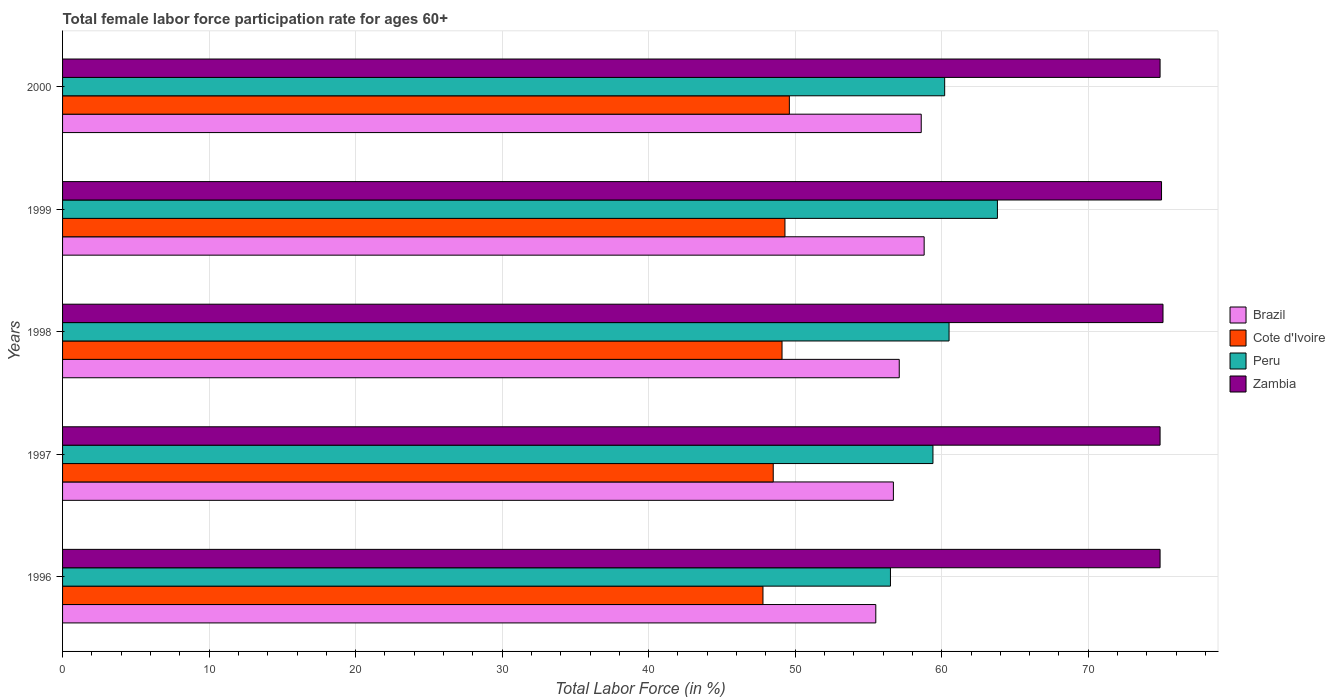How many groups of bars are there?
Offer a very short reply. 5. Are the number of bars per tick equal to the number of legend labels?
Provide a short and direct response. Yes. In how many cases, is the number of bars for a given year not equal to the number of legend labels?
Your answer should be very brief. 0. What is the female labor force participation rate in Peru in 2000?
Provide a succinct answer. 60.2. Across all years, what is the maximum female labor force participation rate in Brazil?
Give a very brief answer. 58.8. Across all years, what is the minimum female labor force participation rate in Brazil?
Provide a short and direct response. 55.5. In which year was the female labor force participation rate in Cote d'Ivoire maximum?
Keep it short and to the point. 2000. In which year was the female labor force participation rate in Zambia minimum?
Give a very brief answer. 1996. What is the total female labor force participation rate in Peru in the graph?
Keep it short and to the point. 300.4. What is the difference between the female labor force participation rate in Brazil in 1996 and that in 1998?
Your answer should be compact. -1.6. What is the difference between the female labor force participation rate in Brazil in 1998 and the female labor force participation rate in Peru in 1999?
Make the answer very short. -6.7. What is the average female labor force participation rate in Brazil per year?
Your answer should be very brief. 57.34. In the year 1998, what is the difference between the female labor force participation rate in Brazil and female labor force participation rate in Zambia?
Your answer should be very brief. -18. What is the ratio of the female labor force participation rate in Zambia in 1998 to that in 2000?
Provide a succinct answer. 1. Is the female labor force participation rate in Peru in 1998 less than that in 2000?
Ensure brevity in your answer.  No. What is the difference between the highest and the second highest female labor force participation rate in Peru?
Your response must be concise. 3.3. What is the difference between the highest and the lowest female labor force participation rate in Cote d'Ivoire?
Ensure brevity in your answer.  1.8. In how many years, is the female labor force participation rate in Cote d'Ivoire greater than the average female labor force participation rate in Cote d'Ivoire taken over all years?
Keep it short and to the point. 3. Is the sum of the female labor force participation rate in Brazil in 1996 and 1998 greater than the maximum female labor force participation rate in Cote d'Ivoire across all years?
Offer a terse response. Yes. What does the 1st bar from the top in 2000 represents?
Make the answer very short. Zambia. What does the 3rd bar from the bottom in 1996 represents?
Your answer should be very brief. Peru. Is it the case that in every year, the sum of the female labor force participation rate in Brazil and female labor force participation rate in Peru is greater than the female labor force participation rate in Zambia?
Keep it short and to the point. Yes. How many bars are there?
Offer a very short reply. 20. Are all the bars in the graph horizontal?
Your answer should be very brief. Yes. Where does the legend appear in the graph?
Make the answer very short. Center right. How many legend labels are there?
Your response must be concise. 4. What is the title of the graph?
Your response must be concise. Total female labor force participation rate for ages 60+. Does "Belarus" appear as one of the legend labels in the graph?
Your answer should be very brief. No. What is the label or title of the X-axis?
Provide a short and direct response. Total Labor Force (in %). What is the label or title of the Y-axis?
Provide a succinct answer. Years. What is the Total Labor Force (in %) in Brazil in 1996?
Keep it short and to the point. 55.5. What is the Total Labor Force (in %) in Cote d'Ivoire in 1996?
Offer a terse response. 47.8. What is the Total Labor Force (in %) of Peru in 1996?
Make the answer very short. 56.5. What is the Total Labor Force (in %) in Zambia in 1996?
Your answer should be very brief. 74.9. What is the Total Labor Force (in %) in Brazil in 1997?
Make the answer very short. 56.7. What is the Total Labor Force (in %) of Cote d'Ivoire in 1997?
Offer a terse response. 48.5. What is the Total Labor Force (in %) of Peru in 1997?
Ensure brevity in your answer.  59.4. What is the Total Labor Force (in %) in Zambia in 1997?
Provide a short and direct response. 74.9. What is the Total Labor Force (in %) in Brazil in 1998?
Offer a very short reply. 57.1. What is the Total Labor Force (in %) in Cote d'Ivoire in 1998?
Make the answer very short. 49.1. What is the Total Labor Force (in %) in Peru in 1998?
Offer a terse response. 60.5. What is the Total Labor Force (in %) of Zambia in 1998?
Your response must be concise. 75.1. What is the Total Labor Force (in %) in Brazil in 1999?
Make the answer very short. 58.8. What is the Total Labor Force (in %) in Cote d'Ivoire in 1999?
Provide a short and direct response. 49.3. What is the Total Labor Force (in %) in Peru in 1999?
Offer a terse response. 63.8. What is the Total Labor Force (in %) in Brazil in 2000?
Offer a terse response. 58.6. What is the Total Labor Force (in %) in Cote d'Ivoire in 2000?
Offer a very short reply. 49.6. What is the Total Labor Force (in %) of Peru in 2000?
Your response must be concise. 60.2. What is the Total Labor Force (in %) of Zambia in 2000?
Make the answer very short. 74.9. Across all years, what is the maximum Total Labor Force (in %) of Brazil?
Offer a terse response. 58.8. Across all years, what is the maximum Total Labor Force (in %) in Cote d'Ivoire?
Offer a terse response. 49.6. Across all years, what is the maximum Total Labor Force (in %) of Peru?
Make the answer very short. 63.8. Across all years, what is the maximum Total Labor Force (in %) of Zambia?
Your response must be concise. 75.1. Across all years, what is the minimum Total Labor Force (in %) of Brazil?
Your answer should be compact. 55.5. Across all years, what is the minimum Total Labor Force (in %) of Cote d'Ivoire?
Provide a succinct answer. 47.8. Across all years, what is the minimum Total Labor Force (in %) in Peru?
Your answer should be compact. 56.5. Across all years, what is the minimum Total Labor Force (in %) of Zambia?
Your response must be concise. 74.9. What is the total Total Labor Force (in %) in Brazil in the graph?
Your answer should be very brief. 286.7. What is the total Total Labor Force (in %) of Cote d'Ivoire in the graph?
Provide a short and direct response. 244.3. What is the total Total Labor Force (in %) of Peru in the graph?
Ensure brevity in your answer.  300.4. What is the total Total Labor Force (in %) in Zambia in the graph?
Give a very brief answer. 374.8. What is the difference between the Total Labor Force (in %) in Brazil in 1996 and that in 1997?
Offer a terse response. -1.2. What is the difference between the Total Labor Force (in %) in Peru in 1996 and that in 1997?
Make the answer very short. -2.9. What is the difference between the Total Labor Force (in %) of Brazil in 1996 and that in 1998?
Give a very brief answer. -1.6. What is the difference between the Total Labor Force (in %) of Cote d'Ivoire in 1996 and that in 1998?
Ensure brevity in your answer.  -1.3. What is the difference between the Total Labor Force (in %) of Peru in 1996 and that in 1998?
Offer a terse response. -4. What is the difference between the Total Labor Force (in %) of Zambia in 1996 and that in 1998?
Your answer should be very brief. -0.2. What is the difference between the Total Labor Force (in %) in Brazil in 1996 and that in 1999?
Ensure brevity in your answer.  -3.3. What is the difference between the Total Labor Force (in %) of Cote d'Ivoire in 1996 and that in 2000?
Make the answer very short. -1.8. What is the difference between the Total Labor Force (in %) in Peru in 1996 and that in 2000?
Offer a very short reply. -3.7. What is the difference between the Total Labor Force (in %) in Brazil in 1997 and that in 1998?
Ensure brevity in your answer.  -0.4. What is the difference between the Total Labor Force (in %) of Cote d'Ivoire in 1997 and that in 1998?
Make the answer very short. -0.6. What is the difference between the Total Labor Force (in %) of Peru in 1997 and that in 1998?
Ensure brevity in your answer.  -1.1. What is the difference between the Total Labor Force (in %) of Brazil in 1997 and that in 1999?
Your answer should be very brief. -2.1. What is the difference between the Total Labor Force (in %) of Peru in 1997 and that in 1999?
Your answer should be very brief. -4.4. What is the difference between the Total Labor Force (in %) in Zambia in 1997 and that in 1999?
Your response must be concise. -0.1. What is the difference between the Total Labor Force (in %) of Peru in 1997 and that in 2000?
Make the answer very short. -0.8. What is the difference between the Total Labor Force (in %) of Peru in 1998 and that in 1999?
Give a very brief answer. -3.3. What is the difference between the Total Labor Force (in %) in Brazil in 1998 and that in 2000?
Provide a short and direct response. -1.5. What is the difference between the Total Labor Force (in %) of Cote d'Ivoire in 1998 and that in 2000?
Keep it short and to the point. -0.5. What is the difference between the Total Labor Force (in %) of Zambia in 1998 and that in 2000?
Provide a short and direct response. 0.2. What is the difference between the Total Labor Force (in %) in Brazil in 1999 and that in 2000?
Offer a terse response. 0.2. What is the difference between the Total Labor Force (in %) in Brazil in 1996 and the Total Labor Force (in %) in Peru in 1997?
Your answer should be compact. -3.9. What is the difference between the Total Labor Force (in %) of Brazil in 1996 and the Total Labor Force (in %) of Zambia in 1997?
Your answer should be very brief. -19.4. What is the difference between the Total Labor Force (in %) of Cote d'Ivoire in 1996 and the Total Labor Force (in %) of Peru in 1997?
Offer a very short reply. -11.6. What is the difference between the Total Labor Force (in %) in Cote d'Ivoire in 1996 and the Total Labor Force (in %) in Zambia in 1997?
Offer a very short reply. -27.1. What is the difference between the Total Labor Force (in %) of Peru in 1996 and the Total Labor Force (in %) of Zambia in 1997?
Make the answer very short. -18.4. What is the difference between the Total Labor Force (in %) in Brazil in 1996 and the Total Labor Force (in %) in Cote d'Ivoire in 1998?
Provide a succinct answer. 6.4. What is the difference between the Total Labor Force (in %) of Brazil in 1996 and the Total Labor Force (in %) of Peru in 1998?
Provide a succinct answer. -5. What is the difference between the Total Labor Force (in %) of Brazil in 1996 and the Total Labor Force (in %) of Zambia in 1998?
Offer a terse response. -19.6. What is the difference between the Total Labor Force (in %) in Cote d'Ivoire in 1996 and the Total Labor Force (in %) in Peru in 1998?
Provide a succinct answer. -12.7. What is the difference between the Total Labor Force (in %) in Cote d'Ivoire in 1996 and the Total Labor Force (in %) in Zambia in 1998?
Your answer should be compact. -27.3. What is the difference between the Total Labor Force (in %) of Peru in 1996 and the Total Labor Force (in %) of Zambia in 1998?
Make the answer very short. -18.6. What is the difference between the Total Labor Force (in %) of Brazil in 1996 and the Total Labor Force (in %) of Cote d'Ivoire in 1999?
Offer a very short reply. 6.2. What is the difference between the Total Labor Force (in %) of Brazil in 1996 and the Total Labor Force (in %) of Peru in 1999?
Provide a short and direct response. -8.3. What is the difference between the Total Labor Force (in %) of Brazil in 1996 and the Total Labor Force (in %) of Zambia in 1999?
Provide a succinct answer. -19.5. What is the difference between the Total Labor Force (in %) of Cote d'Ivoire in 1996 and the Total Labor Force (in %) of Peru in 1999?
Ensure brevity in your answer.  -16. What is the difference between the Total Labor Force (in %) of Cote d'Ivoire in 1996 and the Total Labor Force (in %) of Zambia in 1999?
Make the answer very short. -27.2. What is the difference between the Total Labor Force (in %) in Peru in 1996 and the Total Labor Force (in %) in Zambia in 1999?
Keep it short and to the point. -18.5. What is the difference between the Total Labor Force (in %) of Brazil in 1996 and the Total Labor Force (in %) of Zambia in 2000?
Your answer should be very brief. -19.4. What is the difference between the Total Labor Force (in %) of Cote d'Ivoire in 1996 and the Total Labor Force (in %) of Peru in 2000?
Provide a short and direct response. -12.4. What is the difference between the Total Labor Force (in %) of Cote d'Ivoire in 1996 and the Total Labor Force (in %) of Zambia in 2000?
Offer a very short reply. -27.1. What is the difference between the Total Labor Force (in %) in Peru in 1996 and the Total Labor Force (in %) in Zambia in 2000?
Your answer should be very brief. -18.4. What is the difference between the Total Labor Force (in %) in Brazil in 1997 and the Total Labor Force (in %) in Zambia in 1998?
Give a very brief answer. -18.4. What is the difference between the Total Labor Force (in %) in Cote d'Ivoire in 1997 and the Total Labor Force (in %) in Zambia in 1998?
Provide a short and direct response. -26.6. What is the difference between the Total Labor Force (in %) of Peru in 1997 and the Total Labor Force (in %) of Zambia in 1998?
Make the answer very short. -15.7. What is the difference between the Total Labor Force (in %) in Brazil in 1997 and the Total Labor Force (in %) in Zambia in 1999?
Make the answer very short. -18.3. What is the difference between the Total Labor Force (in %) in Cote d'Ivoire in 1997 and the Total Labor Force (in %) in Peru in 1999?
Your answer should be compact. -15.3. What is the difference between the Total Labor Force (in %) in Cote d'Ivoire in 1997 and the Total Labor Force (in %) in Zambia in 1999?
Provide a succinct answer. -26.5. What is the difference between the Total Labor Force (in %) in Peru in 1997 and the Total Labor Force (in %) in Zambia in 1999?
Your response must be concise. -15.6. What is the difference between the Total Labor Force (in %) of Brazil in 1997 and the Total Labor Force (in %) of Cote d'Ivoire in 2000?
Your response must be concise. 7.1. What is the difference between the Total Labor Force (in %) of Brazil in 1997 and the Total Labor Force (in %) of Peru in 2000?
Make the answer very short. -3.5. What is the difference between the Total Labor Force (in %) in Brazil in 1997 and the Total Labor Force (in %) in Zambia in 2000?
Ensure brevity in your answer.  -18.2. What is the difference between the Total Labor Force (in %) of Cote d'Ivoire in 1997 and the Total Labor Force (in %) of Peru in 2000?
Make the answer very short. -11.7. What is the difference between the Total Labor Force (in %) in Cote d'Ivoire in 1997 and the Total Labor Force (in %) in Zambia in 2000?
Ensure brevity in your answer.  -26.4. What is the difference between the Total Labor Force (in %) in Peru in 1997 and the Total Labor Force (in %) in Zambia in 2000?
Offer a very short reply. -15.5. What is the difference between the Total Labor Force (in %) in Brazil in 1998 and the Total Labor Force (in %) in Zambia in 1999?
Offer a terse response. -17.9. What is the difference between the Total Labor Force (in %) in Cote d'Ivoire in 1998 and the Total Labor Force (in %) in Peru in 1999?
Your answer should be very brief. -14.7. What is the difference between the Total Labor Force (in %) of Cote d'Ivoire in 1998 and the Total Labor Force (in %) of Zambia in 1999?
Your answer should be very brief. -25.9. What is the difference between the Total Labor Force (in %) of Peru in 1998 and the Total Labor Force (in %) of Zambia in 1999?
Offer a terse response. -14.5. What is the difference between the Total Labor Force (in %) of Brazil in 1998 and the Total Labor Force (in %) of Peru in 2000?
Your answer should be compact. -3.1. What is the difference between the Total Labor Force (in %) in Brazil in 1998 and the Total Labor Force (in %) in Zambia in 2000?
Make the answer very short. -17.8. What is the difference between the Total Labor Force (in %) of Cote d'Ivoire in 1998 and the Total Labor Force (in %) of Zambia in 2000?
Make the answer very short. -25.8. What is the difference between the Total Labor Force (in %) of Peru in 1998 and the Total Labor Force (in %) of Zambia in 2000?
Your answer should be very brief. -14.4. What is the difference between the Total Labor Force (in %) in Brazil in 1999 and the Total Labor Force (in %) in Peru in 2000?
Give a very brief answer. -1.4. What is the difference between the Total Labor Force (in %) in Brazil in 1999 and the Total Labor Force (in %) in Zambia in 2000?
Give a very brief answer. -16.1. What is the difference between the Total Labor Force (in %) of Cote d'Ivoire in 1999 and the Total Labor Force (in %) of Peru in 2000?
Your response must be concise. -10.9. What is the difference between the Total Labor Force (in %) in Cote d'Ivoire in 1999 and the Total Labor Force (in %) in Zambia in 2000?
Give a very brief answer. -25.6. What is the average Total Labor Force (in %) in Brazil per year?
Provide a short and direct response. 57.34. What is the average Total Labor Force (in %) of Cote d'Ivoire per year?
Ensure brevity in your answer.  48.86. What is the average Total Labor Force (in %) in Peru per year?
Offer a very short reply. 60.08. What is the average Total Labor Force (in %) of Zambia per year?
Your answer should be very brief. 74.96. In the year 1996, what is the difference between the Total Labor Force (in %) of Brazil and Total Labor Force (in %) of Cote d'Ivoire?
Your answer should be compact. 7.7. In the year 1996, what is the difference between the Total Labor Force (in %) in Brazil and Total Labor Force (in %) in Peru?
Offer a terse response. -1. In the year 1996, what is the difference between the Total Labor Force (in %) of Brazil and Total Labor Force (in %) of Zambia?
Make the answer very short. -19.4. In the year 1996, what is the difference between the Total Labor Force (in %) of Cote d'Ivoire and Total Labor Force (in %) of Zambia?
Your answer should be compact. -27.1. In the year 1996, what is the difference between the Total Labor Force (in %) in Peru and Total Labor Force (in %) in Zambia?
Keep it short and to the point. -18.4. In the year 1997, what is the difference between the Total Labor Force (in %) in Brazil and Total Labor Force (in %) in Cote d'Ivoire?
Your answer should be very brief. 8.2. In the year 1997, what is the difference between the Total Labor Force (in %) of Brazil and Total Labor Force (in %) of Zambia?
Your answer should be compact. -18.2. In the year 1997, what is the difference between the Total Labor Force (in %) in Cote d'Ivoire and Total Labor Force (in %) in Zambia?
Your answer should be compact. -26.4. In the year 1997, what is the difference between the Total Labor Force (in %) of Peru and Total Labor Force (in %) of Zambia?
Give a very brief answer. -15.5. In the year 1998, what is the difference between the Total Labor Force (in %) in Brazil and Total Labor Force (in %) in Peru?
Offer a terse response. -3.4. In the year 1998, what is the difference between the Total Labor Force (in %) in Brazil and Total Labor Force (in %) in Zambia?
Offer a terse response. -18. In the year 1998, what is the difference between the Total Labor Force (in %) in Peru and Total Labor Force (in %) in Zambia?
Offer a very short reply. -14.6. In the year 1999, what is the difference between the Total Labor Force (in %) of Brazil and Total Labor Force (in %) of Zambia?
Provide a short and direct response. -16.2. In the year 1999, what is the difference between the Total Labor Force (in %) of Cote d'Ivoire and Total Labor Force (in %) of Peru?
Provide a succinct answer. -14.5. In the year 1999, what is the difference between the Total Labor Force (in %) in Cote d'Ivoire and Total Labor Force (in %) in Zambia?
Provide a succinct answer. -25.7. In the year 1999, what is the difference between the Total Labor Force (in %) of Peru and Total Labor Force (in %) of Zambia?
Offer a terse response. -11.2. In the year 2000, what is the difference between the Total Labor Force (in %) in Brazil and Total Labor Force (in %) in Zambia?
Offer a very short reply. -16.3. In the year 2000, what is the difference between the Total Labor Force (in %) of Cote d'Ivoire and Total Labor Force (in %) of Zambia?
Offer a terse response. -25.3. In the year 2000, what is the difference between the Total Labor Force (in %) of Peru and Total Labor Force (in %) of Zambia?
Your answer should be compact. -14.7. What is the ratio of the Total Labor Force (in %) of Brazil in 1996 to that in 1997?
Provide a succinct answer. 0.98. What is the ratio of the Total Labor Force (in %) in Cote d'Ivoire in 1996 to that in 1997?
Offer a terse response. 0.99. What is the ratio of the Total Labor Force (in %) in Peru in 1996 to that in 1997?
Provide a short and direct response. 0.95. What is the ratio of the Total Labor Force (in %) in Brazil in 1996 to that in 1998?
Your response must be concise. 0.97. What is the ratio of the Total Labor Force (in %) in Cote d'Ivoire in 1996 to that in 1998?
Offer a terse response. 0.97. What is the ratio of the Total Labor Force (in %) in Peru in 1996 to that in 1998?
Your answer should be very brief. 0.93. What is the ratio of the Total Labor Force (in %) in Brazil in 1996 to that in 1999?
Offer a terse response. 0.94. What is the ratio of the Total Labor Force (in %) in Cote d'Ivoire in 1996 to that in 1999?
Provide a succinct answer. 0.97. What is the ratio of the Total Labor Force (in %) of Peru in 1996 to that in 1999?
Your response must be concise. 0.89. What is the ratio of the Total Labor Force (in %) of Brazil in 1996 to that in 2000?
Ensure brevity in your answer.  0.95. What is the ratio of the Total Labor Force (in %) of Cote d'Ivoire in 1996 to that in 2000?
Make the answer very short. 0.96. What is the ratio of the Total Labor Force (in %) of Peru in 1996 to that in 2000?
Make the answer very short. 0.94. What is the ratio of the Total Labor Force (in %) of Zambia in 1996 to that in 2000?
Give a very brief answer. 1. What is the ratio of the Total Labor Force (in %) in Brazil in 1997 to that in 1998?
Offer a terse response. 0.99. What is the ratio of the Total Labor Force (in %) of Cote d'Ivoire in 1997 to that in 1998?
Your answer should be compact. 0.99. What is the ratio of the Total Labor Force (in %) in Peru in 1997 to that in 1998?
Your response must be concise. 0.98. What is the ratio of the Total Labor Force (in %) in Cote d'Ivoire in 1997 to that in 1999?
Your answer should be very brief. 0.98. What is the ratio of the Total Labor Force (in %) of Zambia in 1997 to that in 1999?
Your answer should be compact. 1. What is the ratio of the Total Labor Force (in %) in Brazil in 1997 to that in 2000?
Your answer should be compact. 0.97. What is the ratio of the Total Labor Force (in %) of Cote d'Ivoire in 1997 to that in 2000?
Your response must be concise. 0.98. What is the ratio of the Total Labor Force (in %) of Peru in 1997 to that in 2000?
Your response must be concise. 0.99. What is the ratio of the Total Labor Force (in %) in Brazil in 1998 to that in 1999?
Your response must be concise. 0.97. What is the ratio of the Total Labor Force (in %) of Cote d'Ivoire in 1998 to that in 1999?
Make the answer very short. 1. What is the ratio of the Total Labor Force (in %) of Peru in 1998 to that in 1999?
Offer a terse response. 0.95. What is the ratio of the Total Labor Force (in %) in Zambia in 1998 to that in 1999?
Offer a terse response. 1. What is the ratio of the Total Labor Force (in %) in Brazil in 1998 to that in 2000?
Give a very brief answer. 0.97. What is the ratio of the Total Labor Force (in %) in Cote d'Ivoire in 1998 to that in 2000?
Give a very brief answer. 0.99. What is the ratio of the Total Labor Force (in %) in Peru in 1998 to that in 2000?
Offer a terse response. 1. What is the ratio of the Total Labor Force (in %) of Zambia in 1998 to that in 2000?
Ensure brevity in your answer.  1. What is the ratio of the Total Labor Force (in %) of Cote d'Ivoire in 1999 to that in 2000?
Provide a short and direct response. 0.99. What is the ratio of the Total Labor Force (in %) of Peru in 1999 to that in 2000?
Your response must be concise. 1.06. What is the difference between the highest and the second highest Total Labor Force (in %) in Peru?
Provide a succinct answer. 3.3. What is the difference between the highest and the lowest Total Labor Force (in %) of Peru?
Provide a short and direct response. 7.3. 